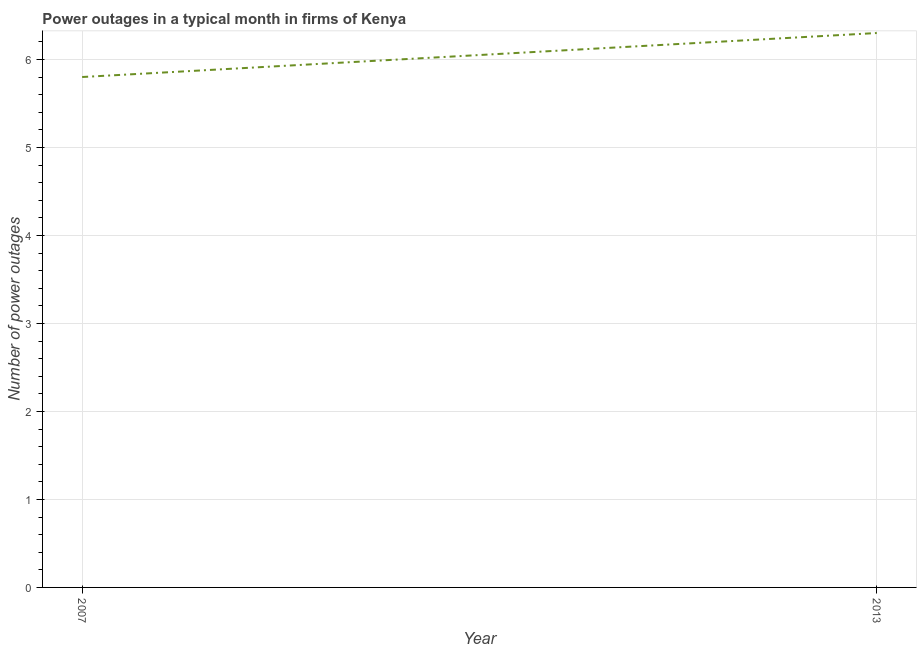What is the number of power outages in 2007?
Ensure brevity in your answer.  5.8. In which year was the number of power outages maximum?
Your response must be concise. 2013. What is the average number of power outages per year?
Provide a short and direct response. 6.05. What is the median number of power outages?
Give a very brief answer. 6.05. Do a majority of the years between 2013 and 2007 (inclusive) have number of power outages greater than 0.4 ?
Offer a terse response. No. What is the ratio of the number of power outages in 2007 to that in 2013?
Ensure brevity in your answer.  0.92. In how many years, is the number of power outages greater than the average number of power outages taken over all years?
Provide a succinct answer. 1. Does the number of power outages monotonically increase over the years?
Give a very brief answer. Yes. How many lines are there?
Provide a short and direct response. 1. How many years are there in the graph?
Offer a terse response. 2. Does the graph contain any zero values?
Your response must be concise. No. Does the graph contain grids?
Your answer should be compact. Yes. What is the title of the graph?
Offer a very short reply. Power outages in a typical month in firms of Kenya. What is the label or title of the X-axis?
Offer a very short reply. Year. What is the label or title of the Y-axis?
Offer a very short reply. Number of power outages. What is the Number of power outages of 2013?
Ensure brevity in your answer.  6.3. What is the difference between the Number of power outages in 2007 and 2013?
Ensure brevity in your answer.  -0.5. What is the ratio of the Number of power outages in 2007 to that in 2013?
Ensure brevity in your answer.  0.92. 